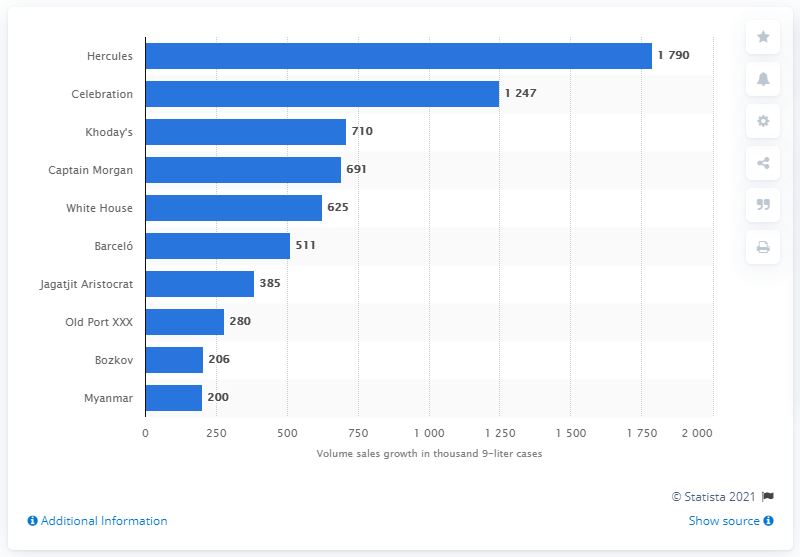Specify some key components in this picture. Captain Morgan increased their sales volume by over 690 thousand 9-liter cases in 2013. 